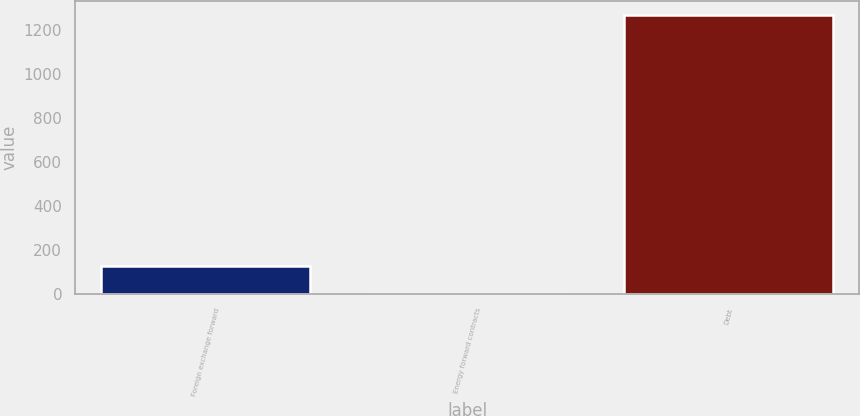<chart> <loc_0><loc_0><loc_500><loc_500><bar_chart><fcel>Foreign exchange forward<fcel>Energy forward contracts<fcel>Debt<nl><fcel>127.15<fcel>0.5<fcel>1267<nl></chart> 